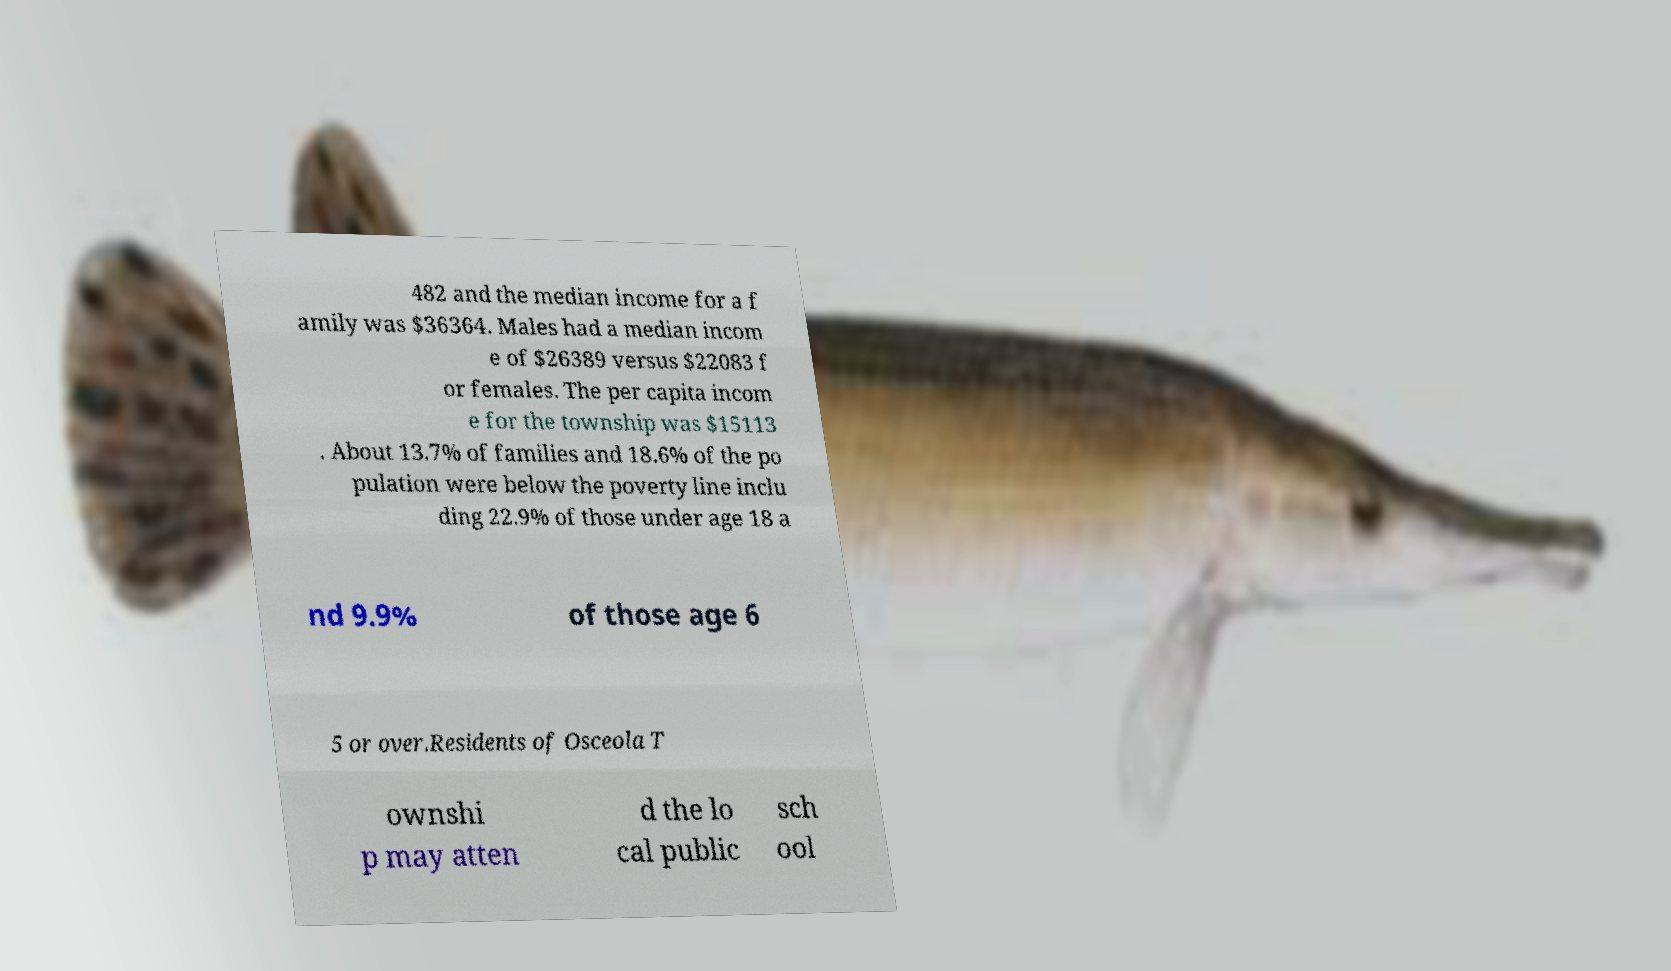Please read and relay the text visible in this image. What does it say? 482 and the median income for a f amily was $36364. Males had a median incom e of $26389 versus $22083 f or females. The per capita incom e for the township was $15113 . About 13.7% of families and 18.6% of the po pulation were below the poverty line inclu ding 22.9% of those under age 18 a nd 9.9% of those age 6 5 or over.Residents of Osceola T ownshi p may atten d the lo cal public sch ool 